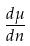Convert formula to latex. <formula><loc_0><loc_0><loc_500><loc_500>\frac { d \mu } { d n }</formula> 